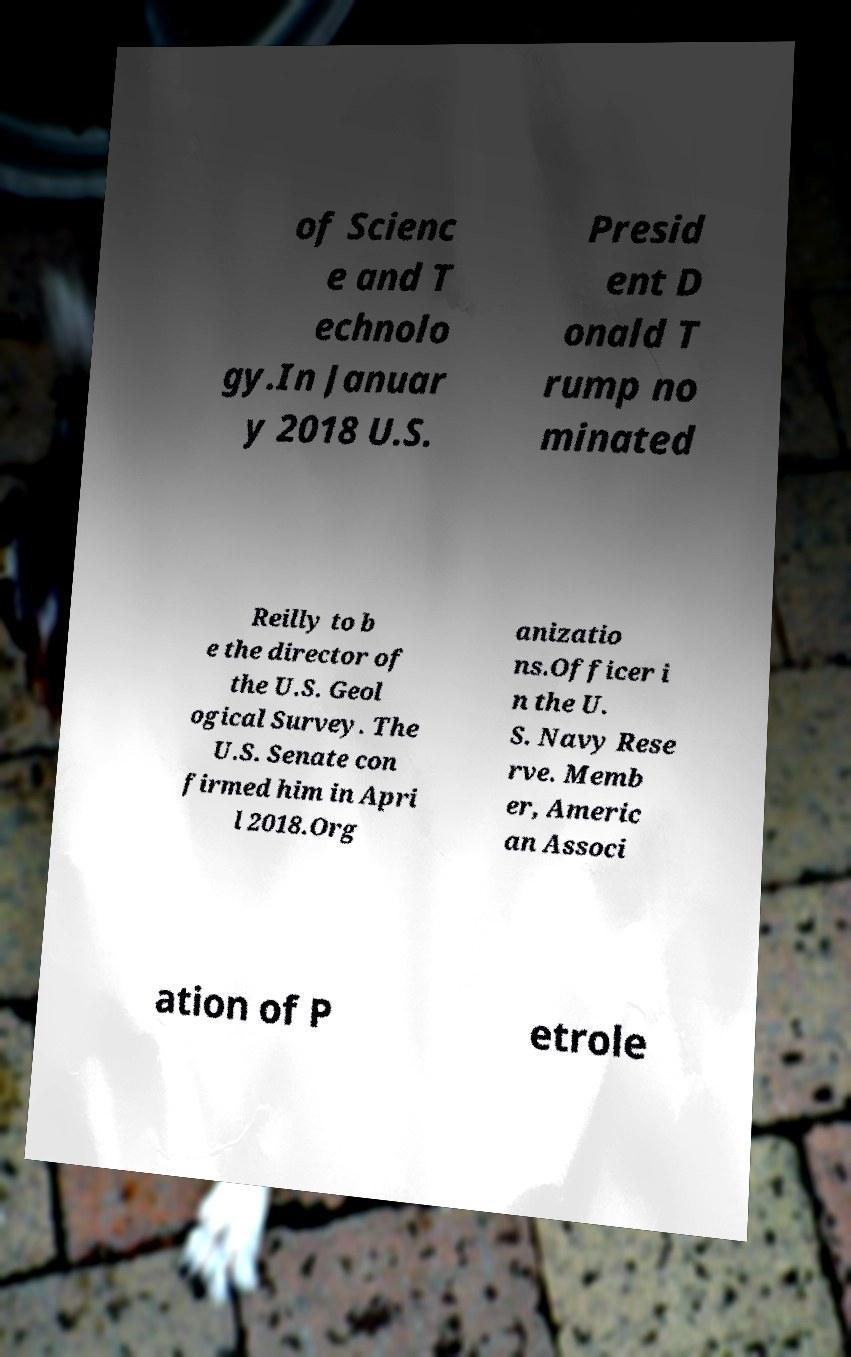Could you assist in decoding the text presented in this image and type it out clearly? of Scienc e and T echnolo gy.In Januar y 2018 U.S. Presid ent D onald T rump no minated Reilly to b e the director of the U.S. Geol ogical Survey. The U.S. Senate con firmed him in Apri l 2018.Org anizatio ns.Officer i n the U. S. Navy Rese rve. Memb er, Americ an Associ ation of P etrole 